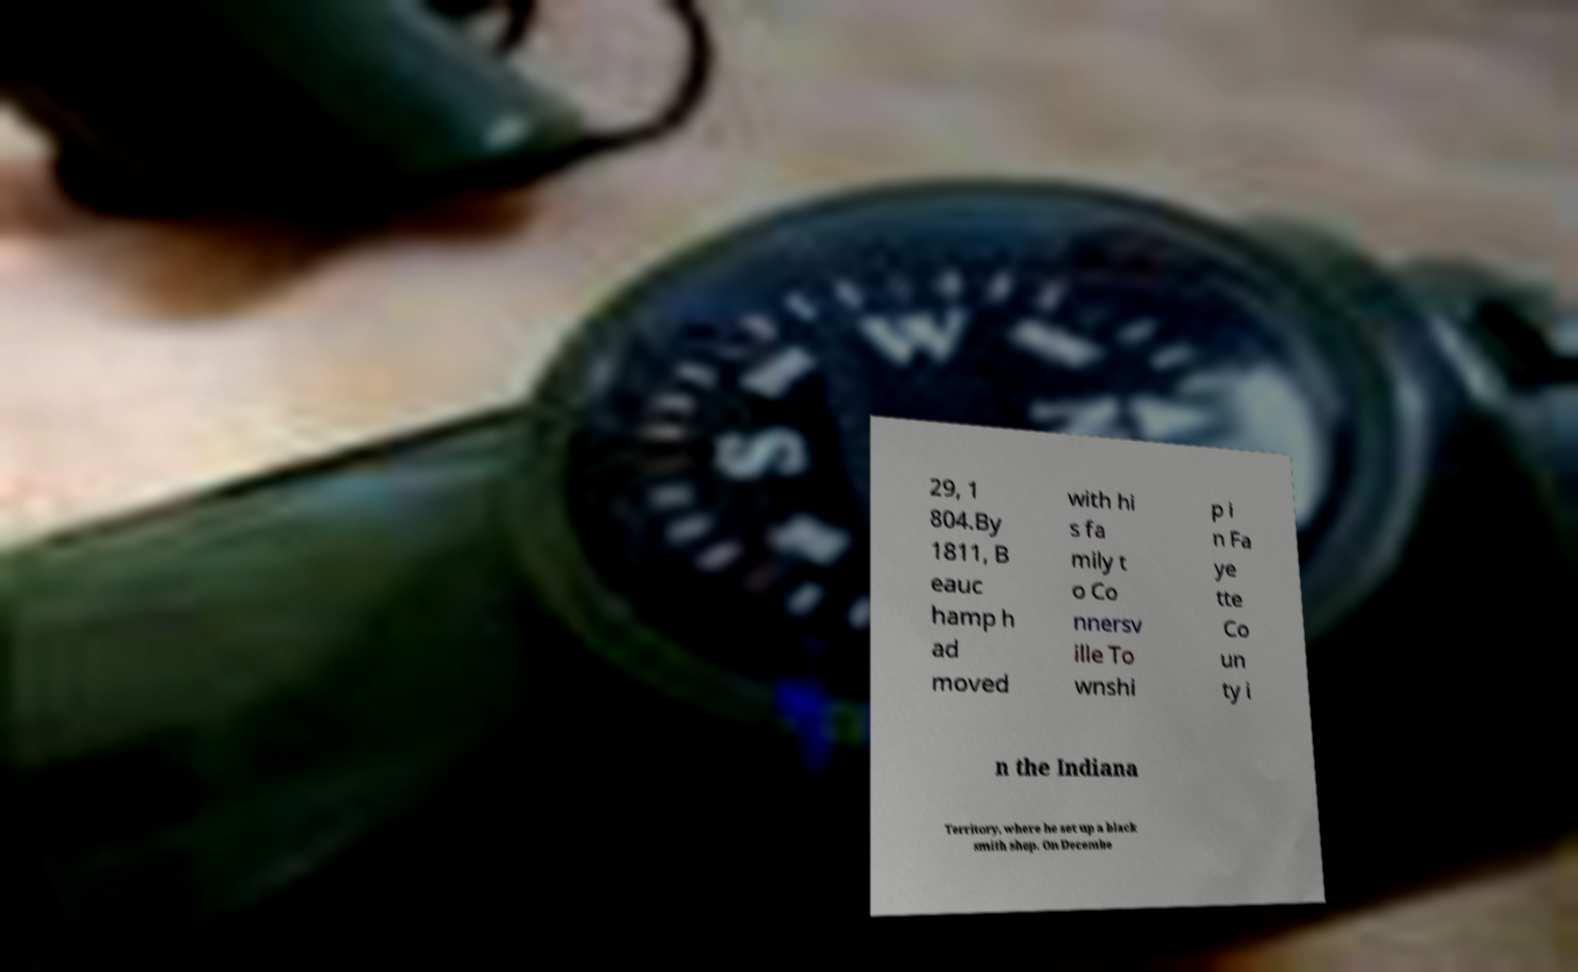What messages or text are displayed in this image? I need them in a readable, typed format. 29, 1 804.By 1811, B eauc hamp h ad moved with hi s fa mily t o Co nnersv ille To wnshi p i n Fa ye tte Co un ty i n the Indiana Territory, where he set up a black smith shop. On Decembe 